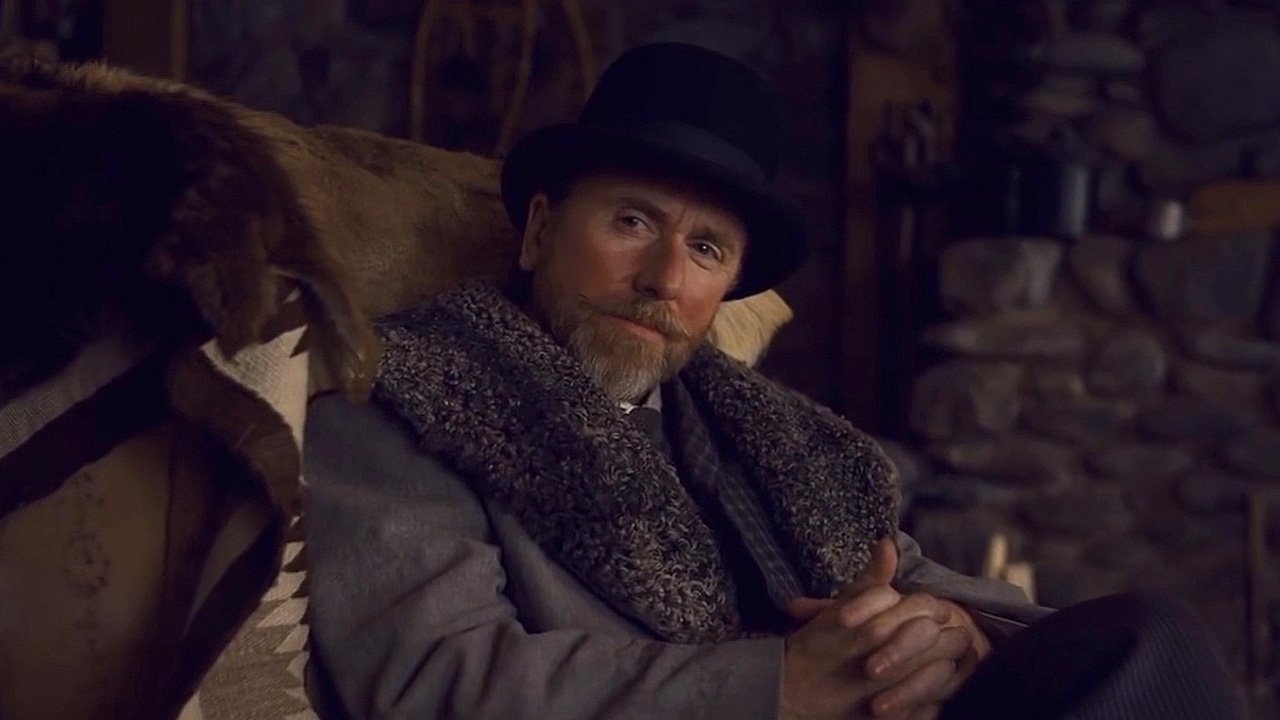What might be the historical or narrative context of this image? The setting and attire of the man suggest a narrative placed in the early 20th century. The costume and the rustic interior might indicate that he is a character from a period drama set in Europe, possibly dealing with themes of industrial era struggles or the nuances of upper-class society during that time. His thoughtful expression might indicate a pivotal moment of decision or reflection within a larger story. 